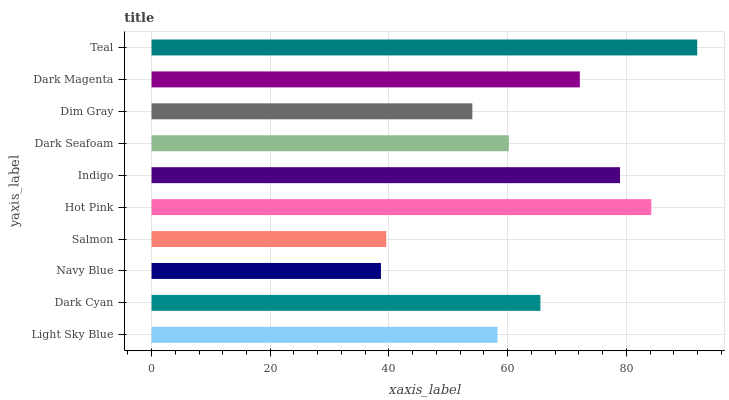Is Navy Blue the minimum?
Answer yes or no. Yes. Is Teal the maximum?
Answer yes or no. Yes. Is Dark Cyan the minimum?
Answer yes or no. No. Is Dark Cyan the maximum?
Answer yes or no. No. Is Dark Cyan greater than Light Sky Blue?
Answer yes or no. Yes. Is Light Sky Blue less than Dark Cyan?
Answer yes or no. Yes. Is Light Sky Blue greater than Dark Cyan?
Answer yes or no. No. Is Dark Cyan less than Light Sky Blue?
Answer yes or no. No. Is Dark Cyan the high median?
Answer yes or no. Yes. Is Dark Seafoam the low median?
Answer yes or no. Yes. Is Indigo the high median?
Answer yes or no. No. Is Dark Magenta the low median?
Answer yes or no. No. 